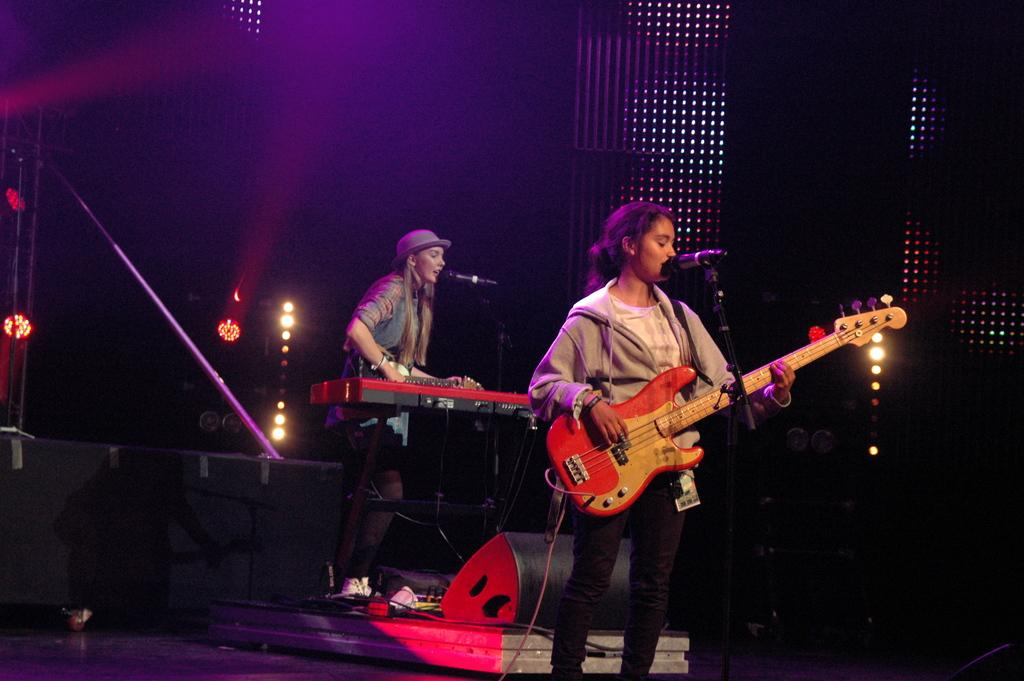How many people are on the stage in the image? There are two persons on a stage in the image. What are the persons on the stage doing? Both persons are playing musical instruments. What can be seen in the background of the image? There are lightnings visible in the background. What type of soap is being used by the persons on the stage? There is no soap present in the image; it features two persons playing musical instruments on a stage with lightnings in the background. What kind of cake is being served to the pets in the image? There are no pets or cake present in the image. 